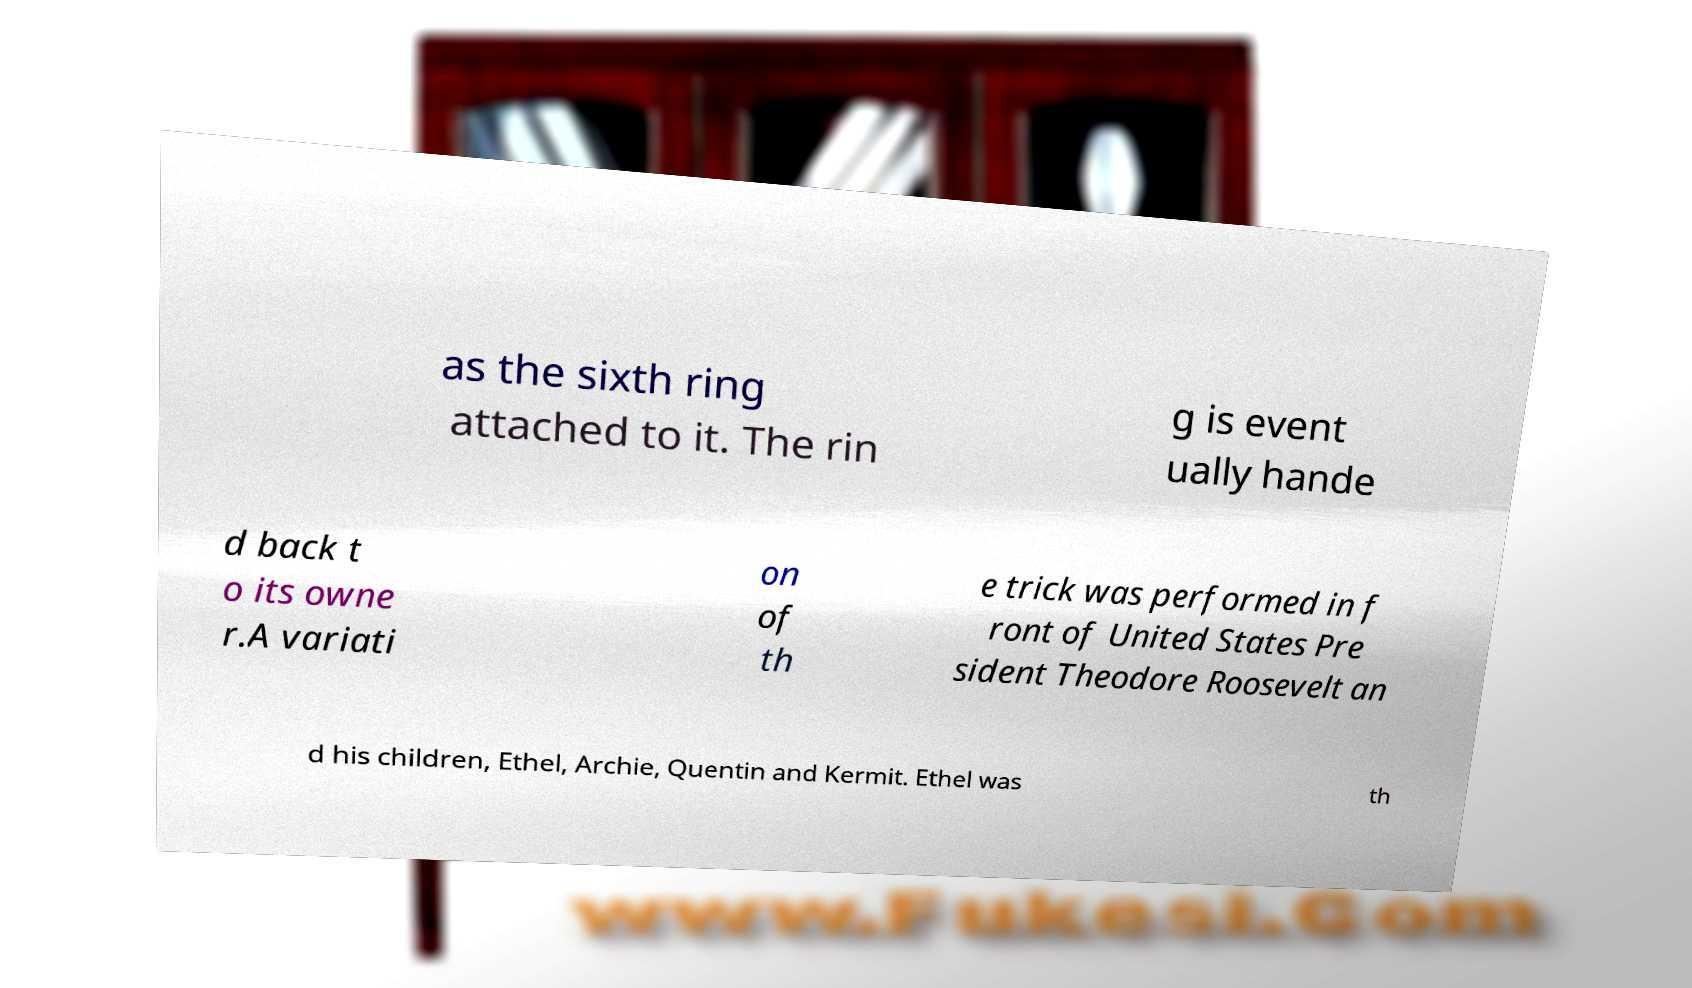For documentation purposes, I need the text within this image transcribed. Could you provide that? as the sixth ring attached to it. The rin g is event ually hande d back t o its owne r.A variati on of th e trick was performed in f ront of United States Pre sident Theodore Roosevelt an d his children, Ethel, Archie, Quentin and Kermit. Ethel was th 